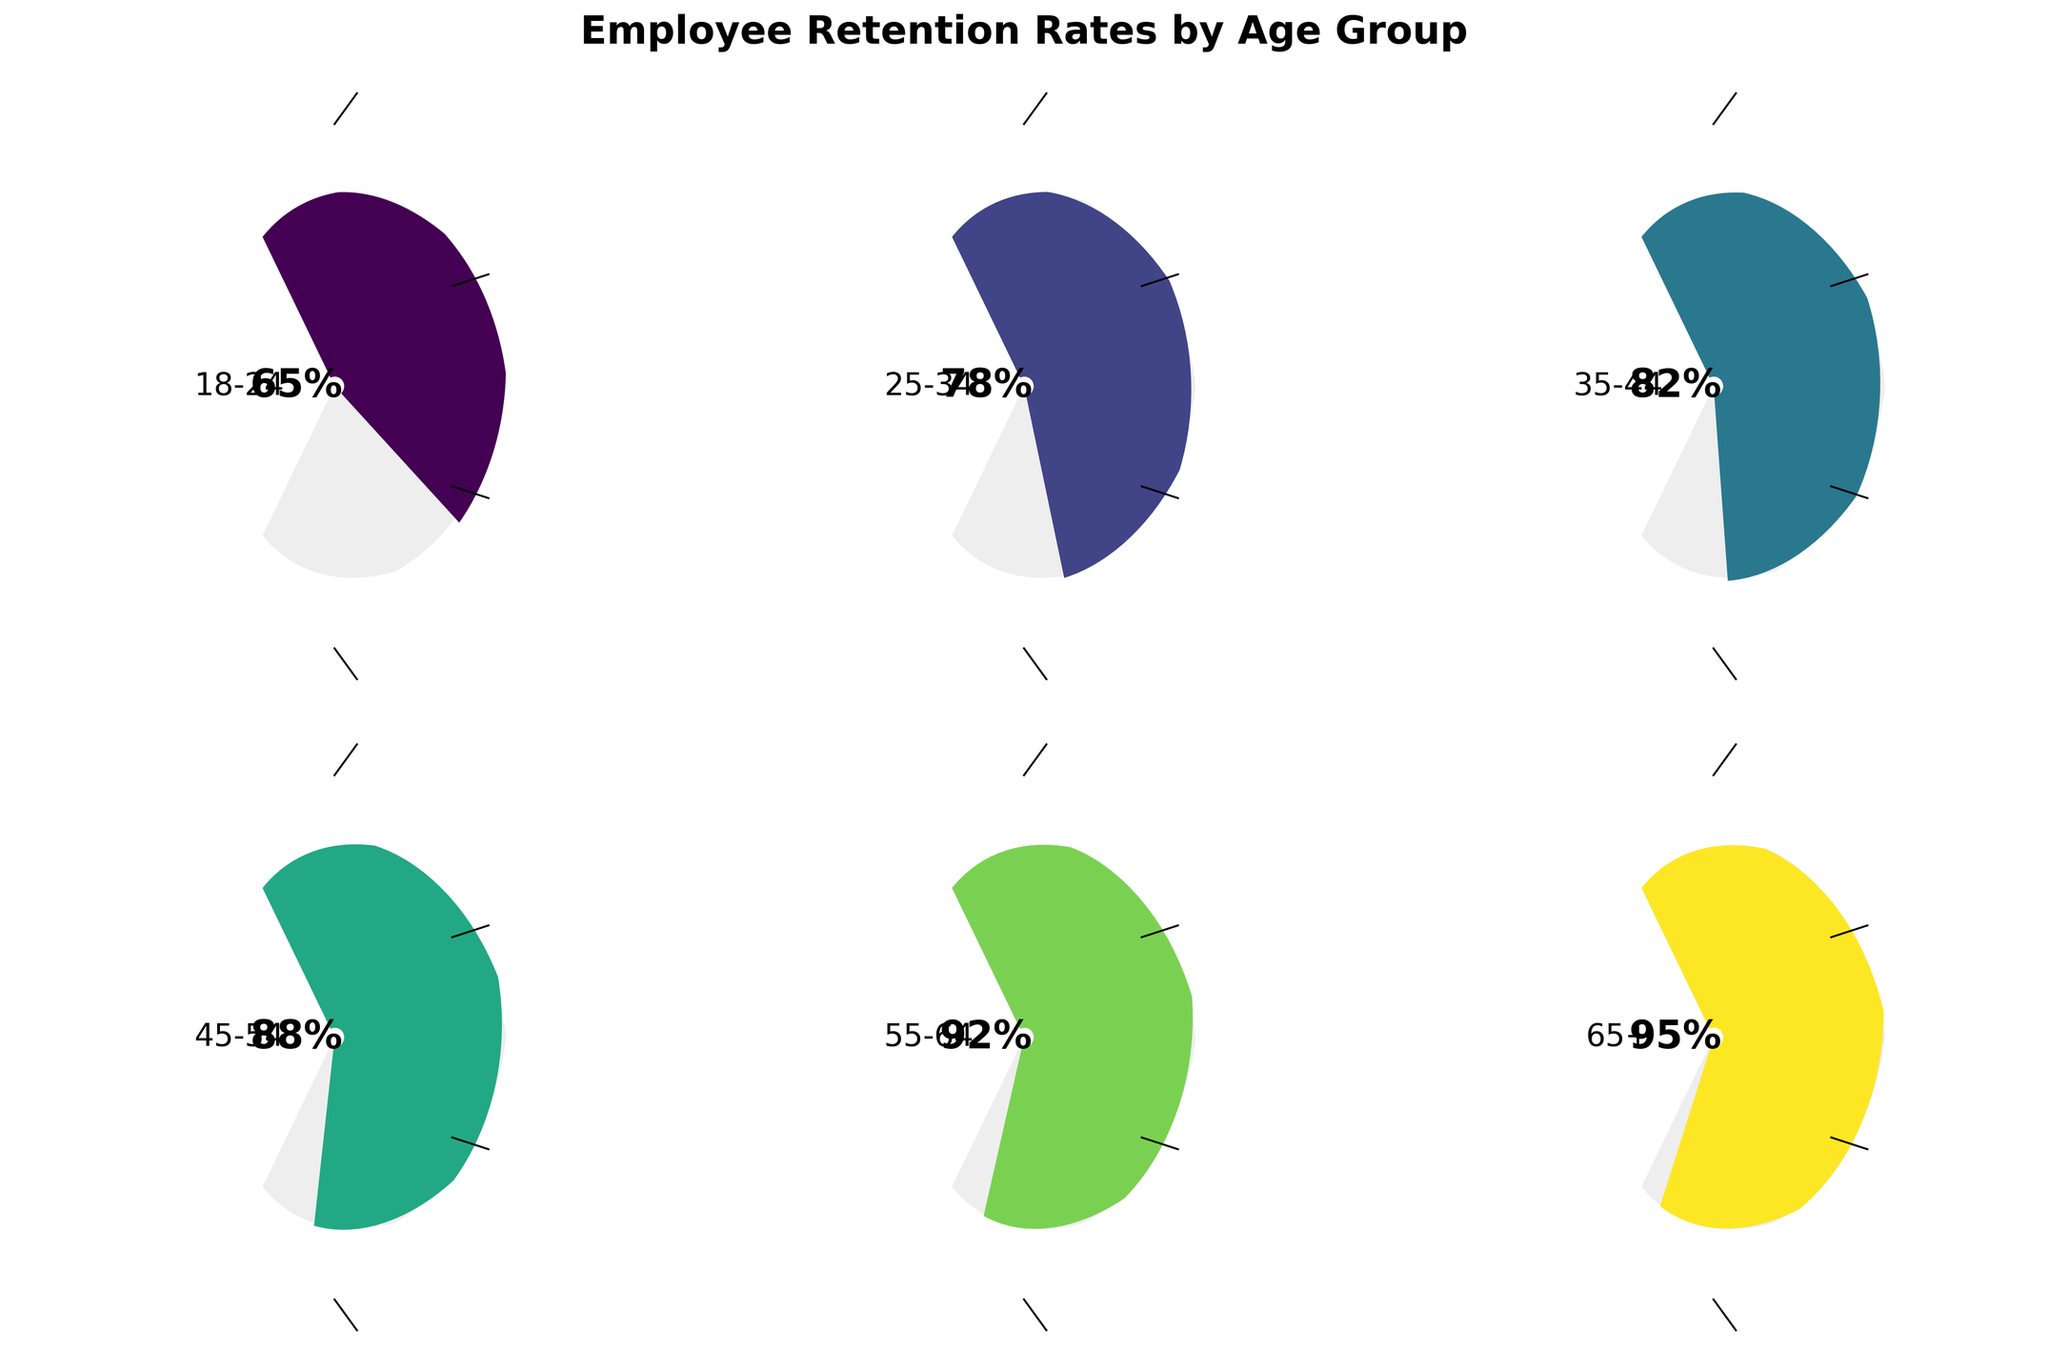What is the retention rate for employees aged 18-24? Locate the gauge chart for the '18-24' age group and read the numerical value displayed at the bottom of the chart.
Answer: 65% Which age group has the highest retention rate? Compare the retention rates displayed on each gauge chart and identify the highest percentage.
Answer: 65+ What is the range of retention rates shown in the figure? Identify the minimum and maximum retention rates by scanning all the gauge charts and noting the lowest and highest values. Calculate the range by subtracting the minimum value (65%) from the maximum value (95%).
Answer: 30% What is the average retention rate across all age groups? Add up all the retention rates (65 + 78 + 82 + 88 + 92 + 95) and divide by the number of age groups (6) to find the average.
Answer: 83.33% How much higher is the retention rate for employees aged 45-54 compared to those aged 18-24? Subtract the retention rate of the '18-24' age group (65%) from the retention rate of the '45-54' age group (88%).
Answer: 23% Are there any age groups with the same retention rate? Scan each gauge chart's retention rate value to see if any two age groups have identical percentages.
Answer: No Which age group has a retention rate closest to 80%? Compare all the retention values to 80% and find the one that is numerically closest (either above or below).
Answer: 35-44 How does the retention rate for employees aged 55-64 compare to the overall average retention rate? First, find the overall average retention rate (83.33%). Then, compare it to the retention rate for the '55-64' age group (92%). The '55-64' age group has a retention rate that is higher than the overall average.
Answer: Higher What is the median retention rate of the age groups? First, list all the retention rates in ascending order: 65, 78, 82, 88, 92, 95. Since there is an even number of observations, the median is the average of the third and fourth values (82 and 88): (82+88)/2 = 85.
Answer: 85 Is the retention rate for employees aged 25-34 greater than 75%? Look at the gauge chart for the '25-34' age group and check if the retention rate (78%) is greater than 75%.
Answer: Yes 